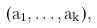Convert formula to latex. <formula><loc_0><loc_0><loc_500><loc_500>( a _ { 1 } , \dots , a _ { k } ) ,</formula> 